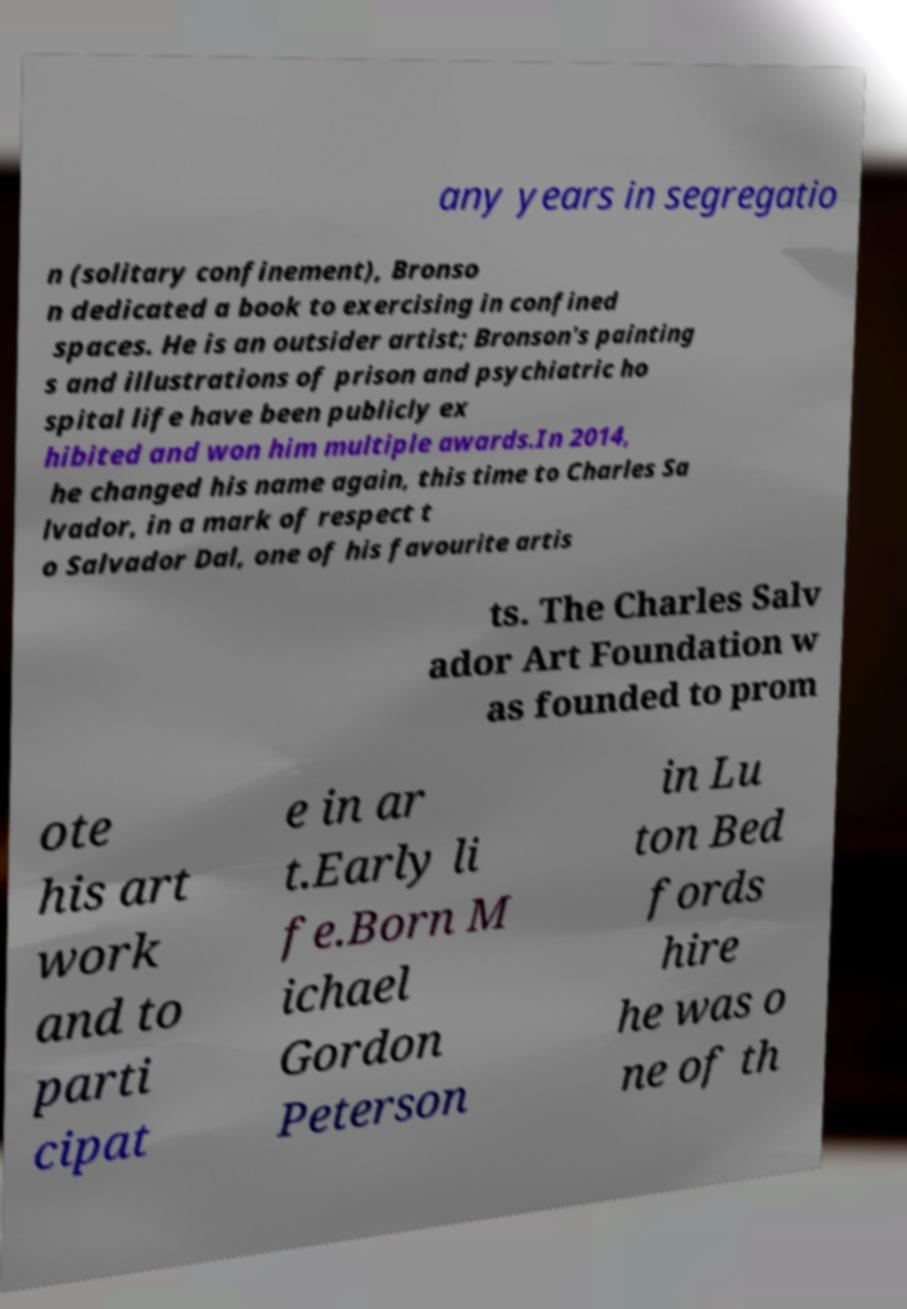There's text embedded in this image that I need extracted. Can you transcribe it verbatim? any years in segregatio n (solitary confinement), Bronso n dedicated a book to exercising in confined spaces. He is an outsider artist; Bronson's painting s and illustrations of prison and psychiatric ho spital life have been publicly ex hibited and won him multiple awards.In 2014, he changed his name again, this time to Charles Sa lvador, in a mark of respect t o Salvador Dal, one of his favourite artis ts. The Charles Salv ador Art Foundation w as founded to prom ote his art work and to parti cipat e in ar t.Early li fe.Born M ichael Gordon Peterson in Lu ton Bed fords hire he was o ne of th 